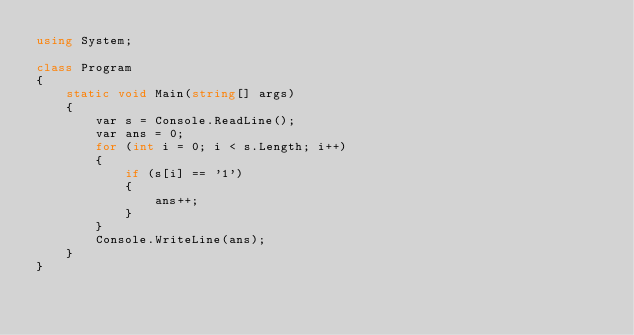Convert code to text. <code><loc_0><loc_0><loc_500><loc_500><_C#_>using System;

class Program
{
    static void Main(string[] args)
    {
        var s = Console.ReadLine();
        var ans = 0;
        for (int i = 0; i < s.Length; i++)
        {
            if (s[i] == '1')
            {
                ans++;
            }
        }
        Console.WriteLine(ans);
    }
}
</code> 